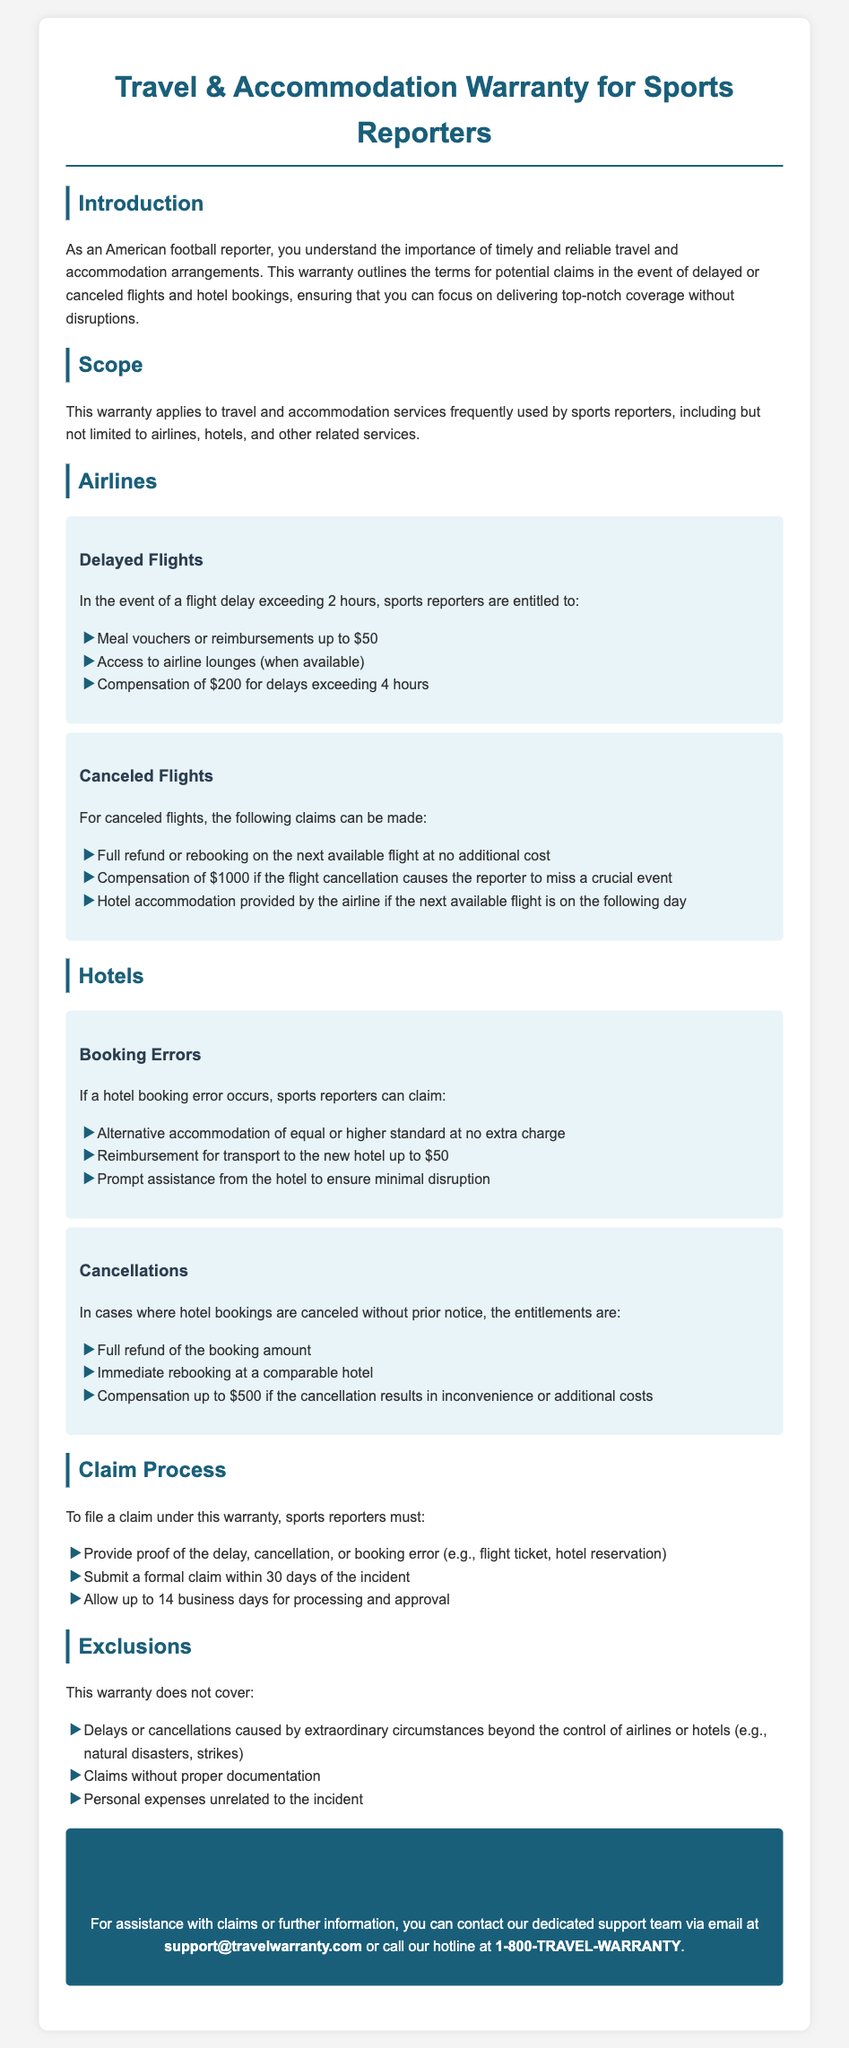What compensation is provided for delayed flights exceeding 4 hours? The document states that compensation of $200 is provided for delays exceeding 4 hours.
Answer: $200 What is the reimbursement amount for transport to a new hotel? The warranty allows for reimbursement for transport to the new hotel up to $50.
Answer: $50 What must reporters provide to file a claim? Reporters must provide proof of the delay, cancellation, or booking error, such as flight ticket or hotel reservation.
Answer: Proof of the delay, cancellation, or booking error What is the compensation amount for missed crucial events due to flight cancellations? The document specifies that compensation of $1000 is available if a flight cancellation causes the reporter to miss a crucial event.
Answer: $1000 How long do reporters have to submit a formal claim after an incident? Reporters must submit a formal claim within 30 days of the incident.
Answer: 30 days What type of circumstances are excluded from coverage under this warranty? The document mentions delays or cancellations caused by extraordinary circumstances beyond the control of airlines or hotels as excluded.
Answer: Extraordinary circumstances What entitlements do reporters have for hotel cancellations without prior notice? Reporters are entitled to a full refund of the booking amount and immediate rebooking at a comparable hotel.
Answer: Full refund of the booking amount and immediate rebooking at a comparable hotel How long can processing and approval of claims take? The document states that reporters should allow up to 14 business days for processing and approval of claims.
Answer: 14 business days 